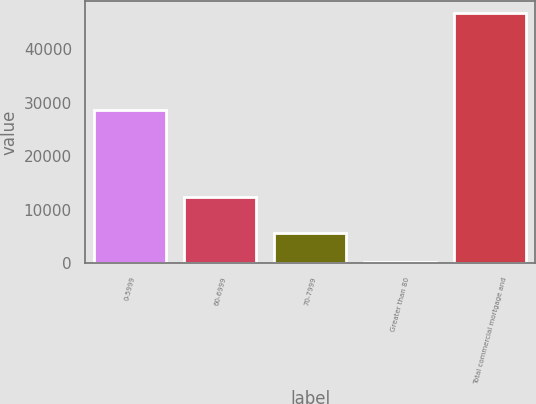Convert chart. <chart><loc_0><loc_0><loc_500><loc_500><bar_chart><fcel>0-5999<fcel>60-6999<fcel>70-7999<fcel>Greater than 80<fcel>Total commercial mortgage and<nl><fcel>28565<fcel>12376<fcel>5668<fcel>119<fcel>46728<nl></chart> 